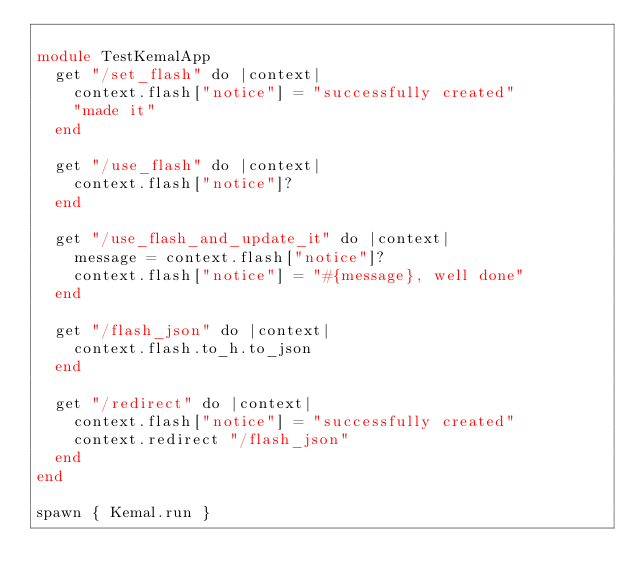Convert code to text. <code><loc_0><loc_0><loc_500><loc_500><_Crystal_>
module TestKemalApp
  get "/set_flash" do |context|
    context.flash["notice"] = "successfully created"
    "made it"
  end

  get "/use_flash" do |context|
    context.flash["notice"]?
  end

  get "/use_flash_and_update_it" do |context|
    message = context.flash["notice"]?
    context.flash["notice"] = "#{message}, well done"
  end

  get "/flash_json" do |context|
    context.flash.to_h.to_json
  end

  get "/redirect" do |context|
    context.flash["notice"] = "successfully created"
    context.redirect "/flash_json"
  end
end

spawn { Kemal.run }
</code> 